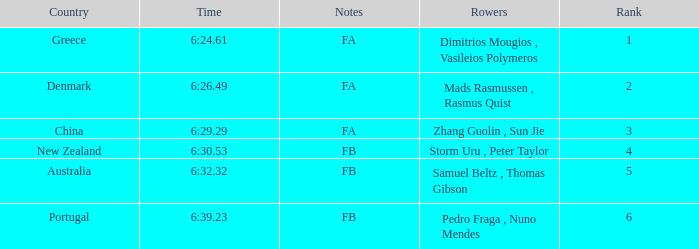What is the names of the rowers that the time was 6:24.61? Dimitrios Mougios , Vasileios Polymeros. 